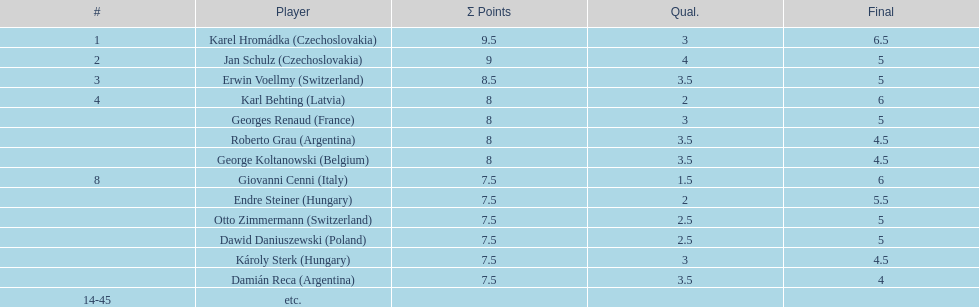Did the two competitors from hungary get more or less combined points than the two competitors from argentina? Less. 